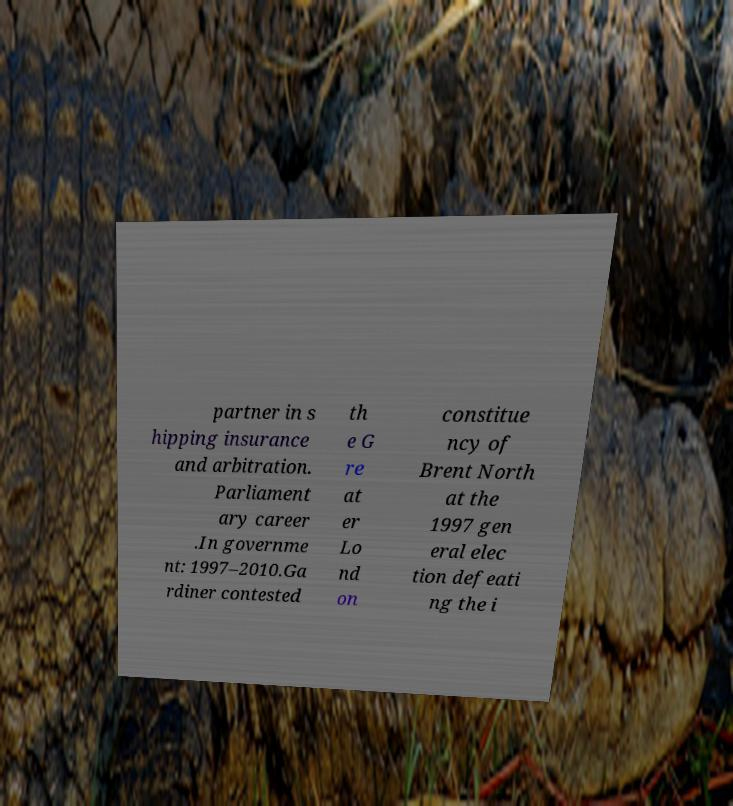Please read and relay the text visible in this image. What does it say? partner in s hipping insurance and arbitration. Parliament ary career .In governme nt: 1997–2010.Ga rdiner contested th e G re at er Lo nd on constitue ncy of Brent North at the 1997 gen eral elec tion defeati ng the i 